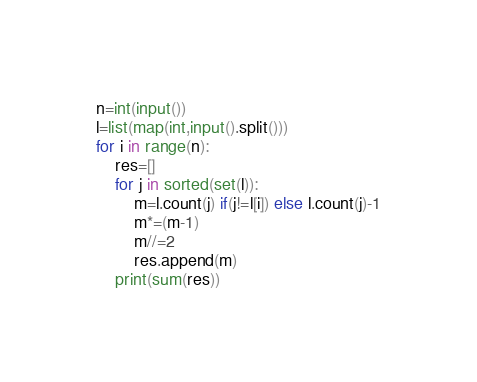<code> <loc_0><loc_0><loc_500><loc_500><_Python_>n=int(input())
l=list(map(int,input().split()))
for i in range(n):
    res=[]
    for j in sorted(set(l)):
        m=l.count(j) if(j!=l[i]) else l.count(j)-1
        m*=(m-1)
        m//=2
        res.append(m)
    print(sum(res))</code> 